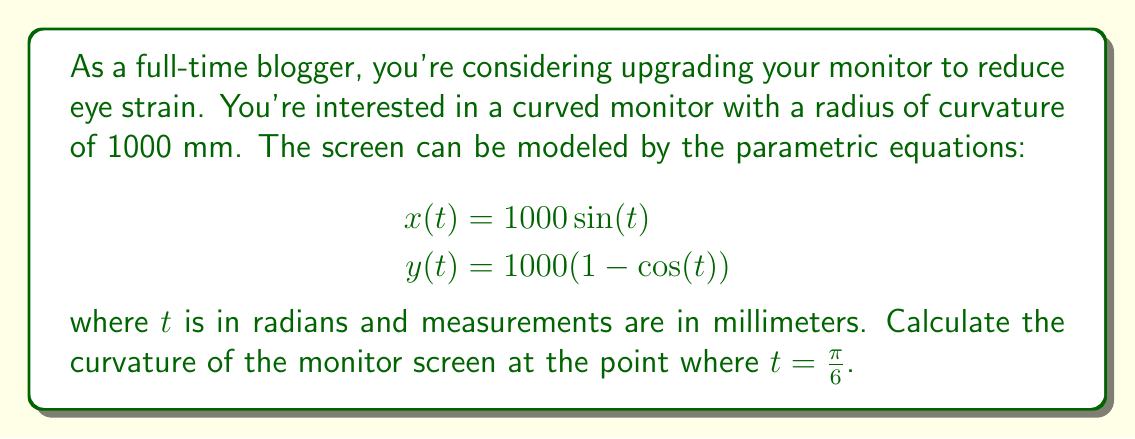Can you solve this math problem? To calculate the curvature of the monitor screen, we'll follow these steps:

1) The formula for curvature $\kappa$ of a curve defined by parametric equations is:

   $$\kappa = \frac{|x'y'' - y'x''|}{(x'^2 + y'^2)^{3/2}}$$

2) Let's find the first and second derivatives of $x$ and $y$ with respect to $t$:

   $$x'(t) = 1000 \cos(t)$$
   $$y'(t) = 1000 \sin(t)$$
   $$x''(t) = -1000 \sin(t)$$
   $$y''(t) = 1000 \cos(t)$$

3) Now, let's substitute these into the curvature formula:

   $$\kappa = \frac{|1000 \cos(t) \cdot 1000 \cos(t) - 1000 \sin(t) \cdot (-1000 \sin(t))|}{(1000^2 \cos^2(t) + 1000^2 \sin^2(t))^{3/2}}$$

4) Simplify:

   $$\kappa = \frac{|1,000,000 (\cos^2(t) + \sin^2(t))|}{1,000,000^{3/2} (\cos^2(t) + \sin^2(t))^{3/2}}$$

5) Note that $\cos^2(t) + \sin^2(t) = 1$ for all $t$, so this simplifies to:

   $$\kappa = \frac{1,000,000}{1,000,000^{3/2}} = \frac{1}{1000} = 0.001$$

6) This result is constant for all $t$, including $t = \frac{\pi}{6}$, which makes sense as we're describing a circular arc with a constant radius of 1000 mm.
Answer: $\kappa = 0.001$ mm$^{-1}$ 